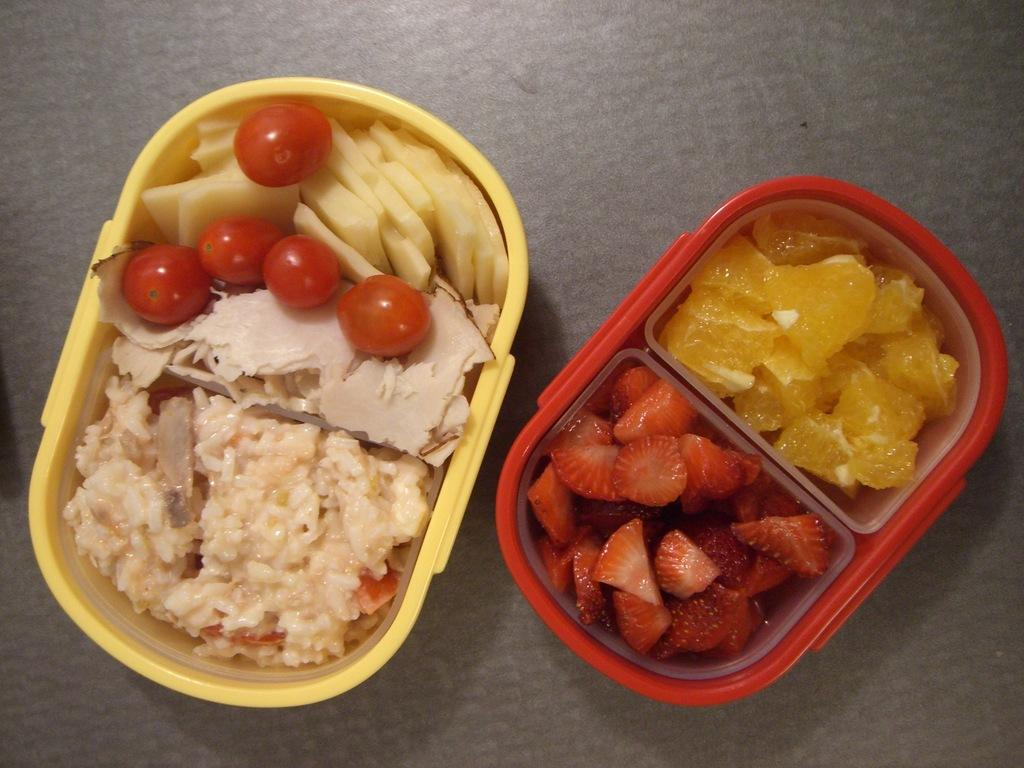What objects can be seen in the image? There are boxes in the image. What is inside the boxes? The boxes contain food items. What type of oil can be seen dripping from the boxes in the image? There is no oil present in the image; it only shows boxes containing food items. 